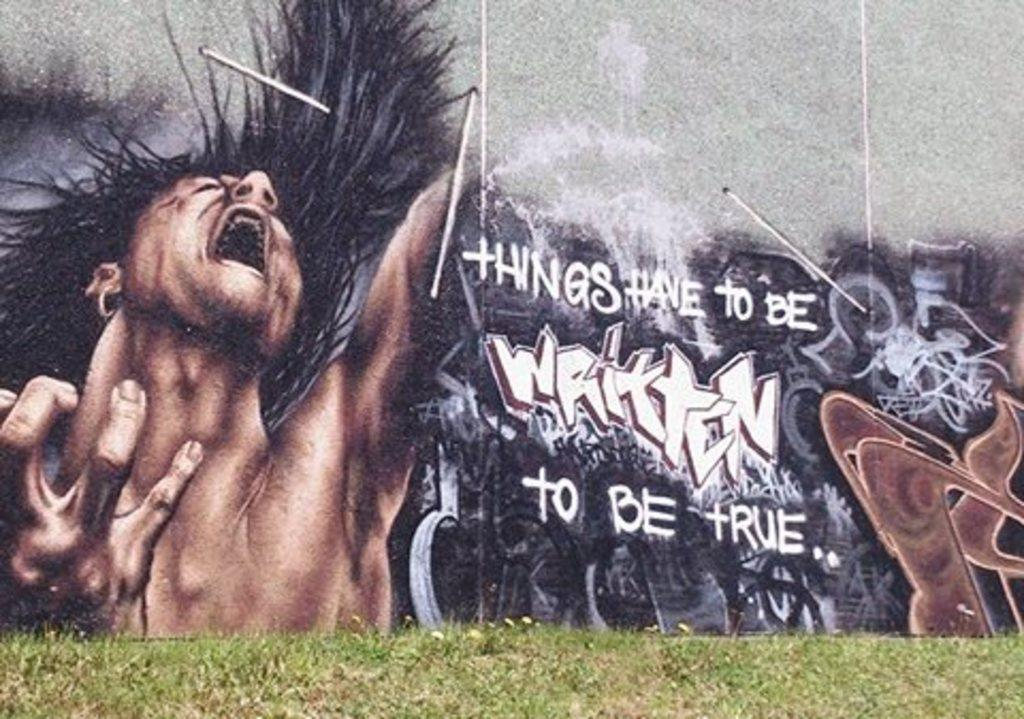<image>
Give a short and clear explanation of the subsequent image. A large mural painted on a building that reads things have to be written to be true. 